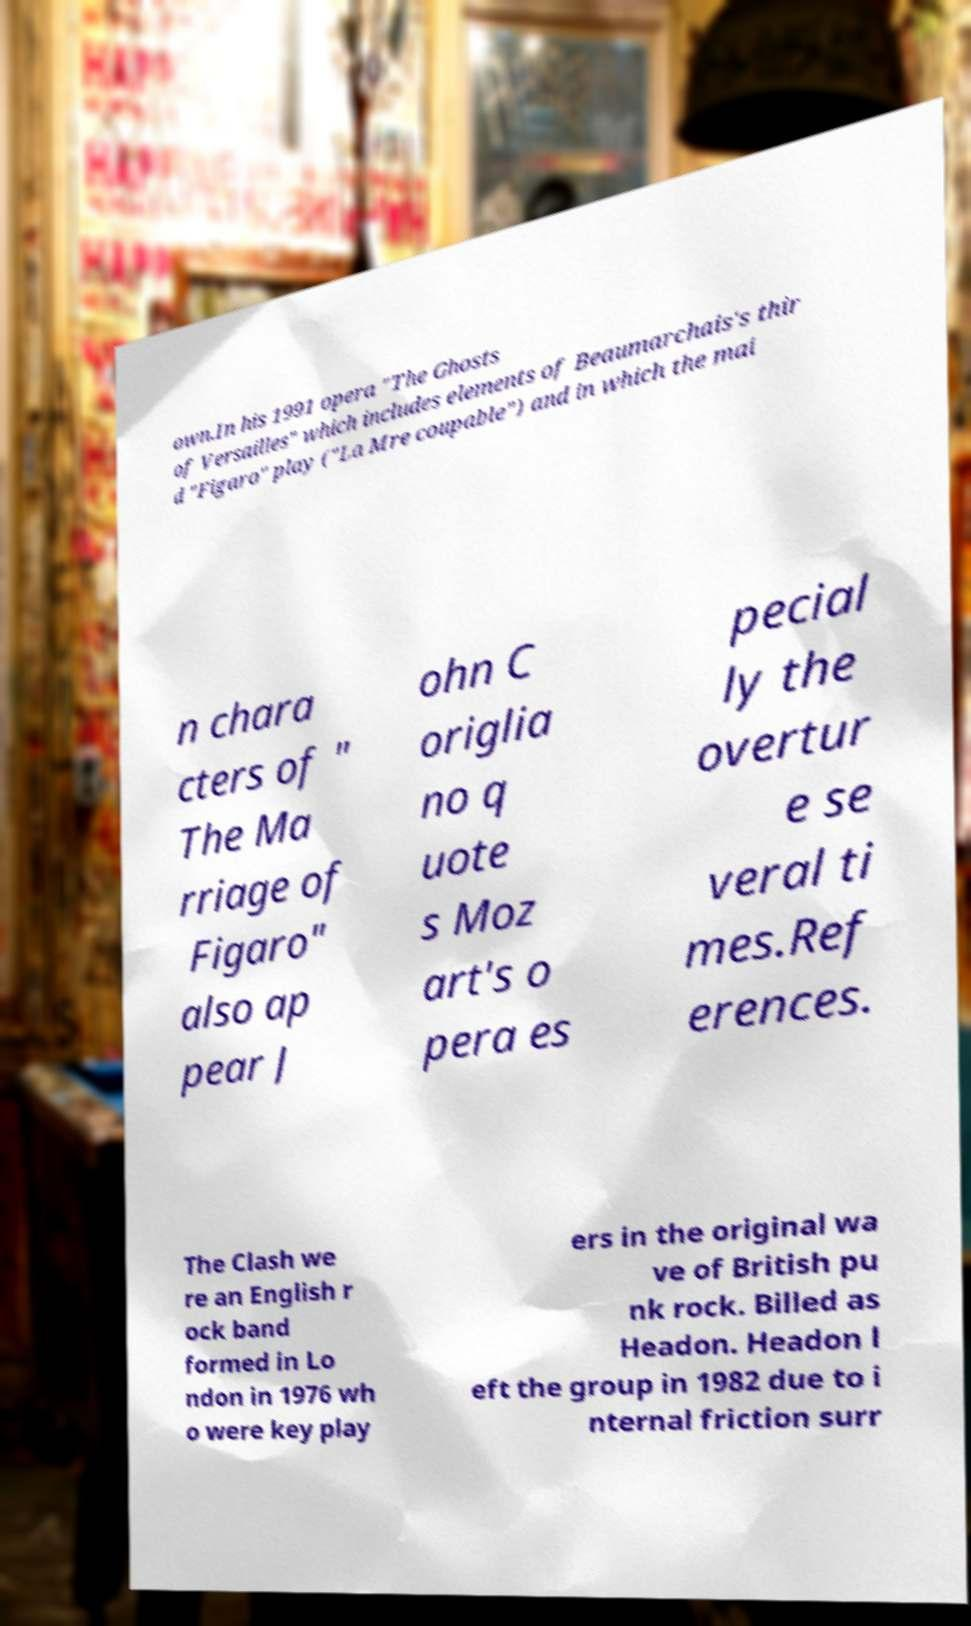Please read and relay the text visible in this image. What does it say? own.In his 1991 opera "The Ghosts of Versailles" which includes elements of Beaumarchais's thir d "Figaro" play ("La Mre coupable") and in which the mai n chara cters of " The Ma rriage of Figaro" also ap pear J ohn C origlia no q uote s Moz art's o pera es pecial ly the overtur e se veral ti mes.Ref erences. The Clash we re an English r ock band formed in Lo ndon in 1976 wh o were key play ers in the original wa ve of British pu nk rock. Billed as Headon. Headon l eft the group in 1982 due to i nternal friction surr 